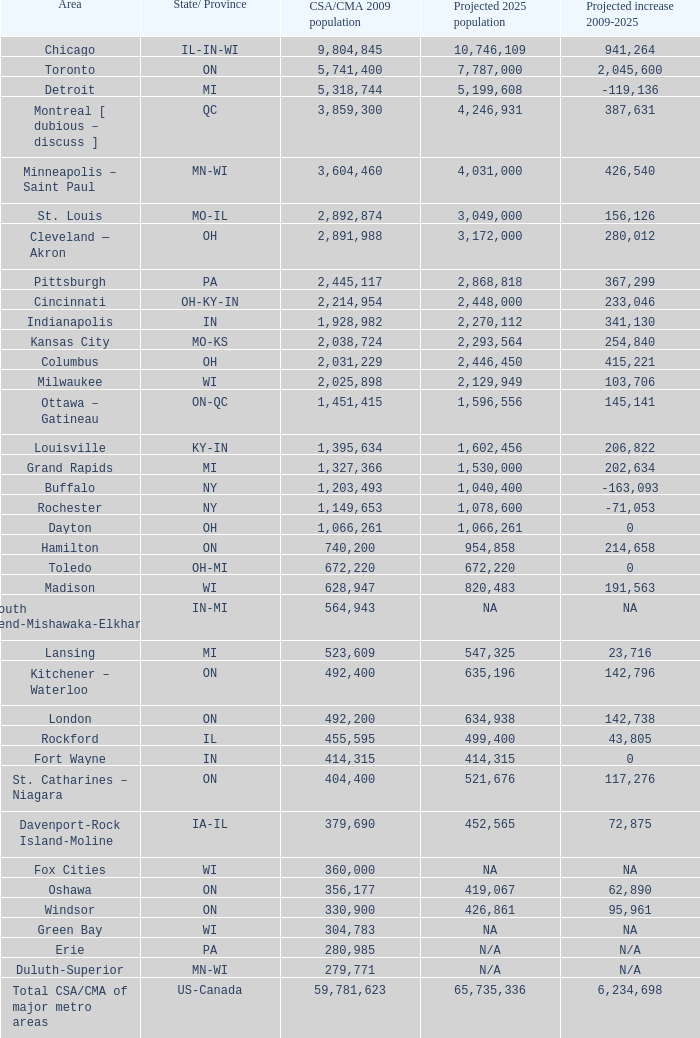What is the number of people living in the iowa-illinois csa/cma region? 379690.0. 